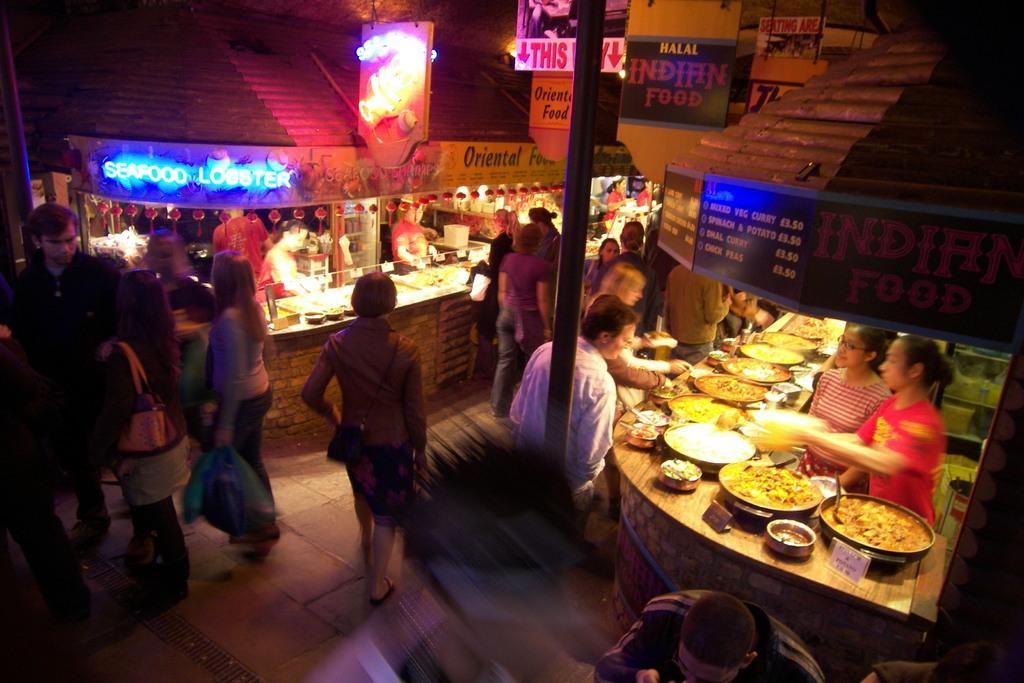Could you give a brief overview of what you see in this image? In this picture there are few people standing and there are few stalls on either sides of them. 